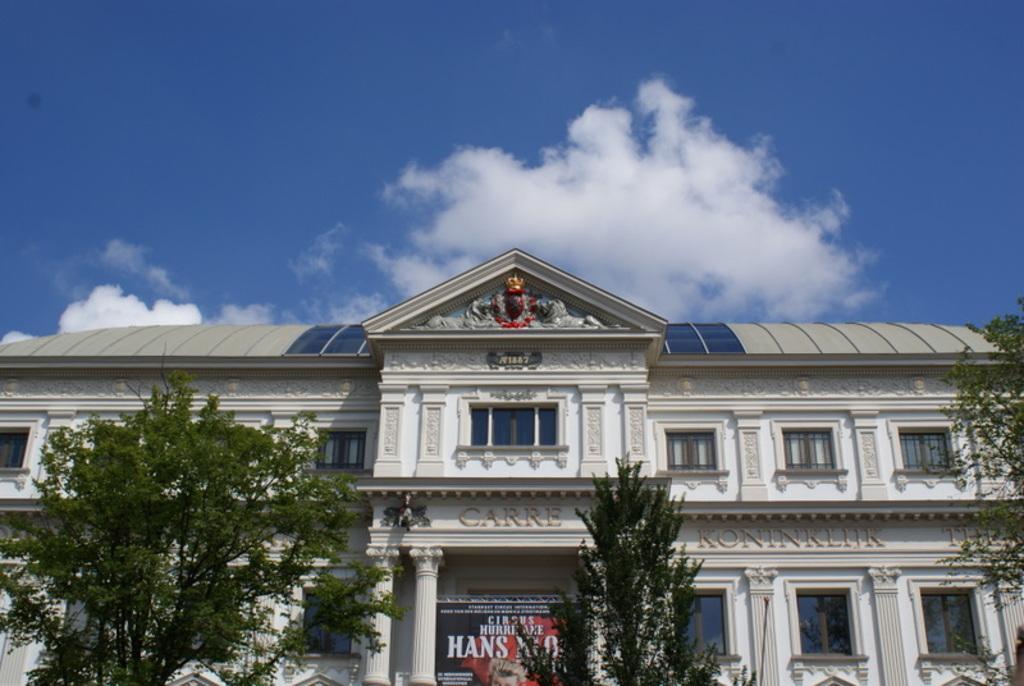Could you give a brief overview of what you see in this image? In this image I can see a building, trees and a board on which something written on it. In the background I can see the sky. 